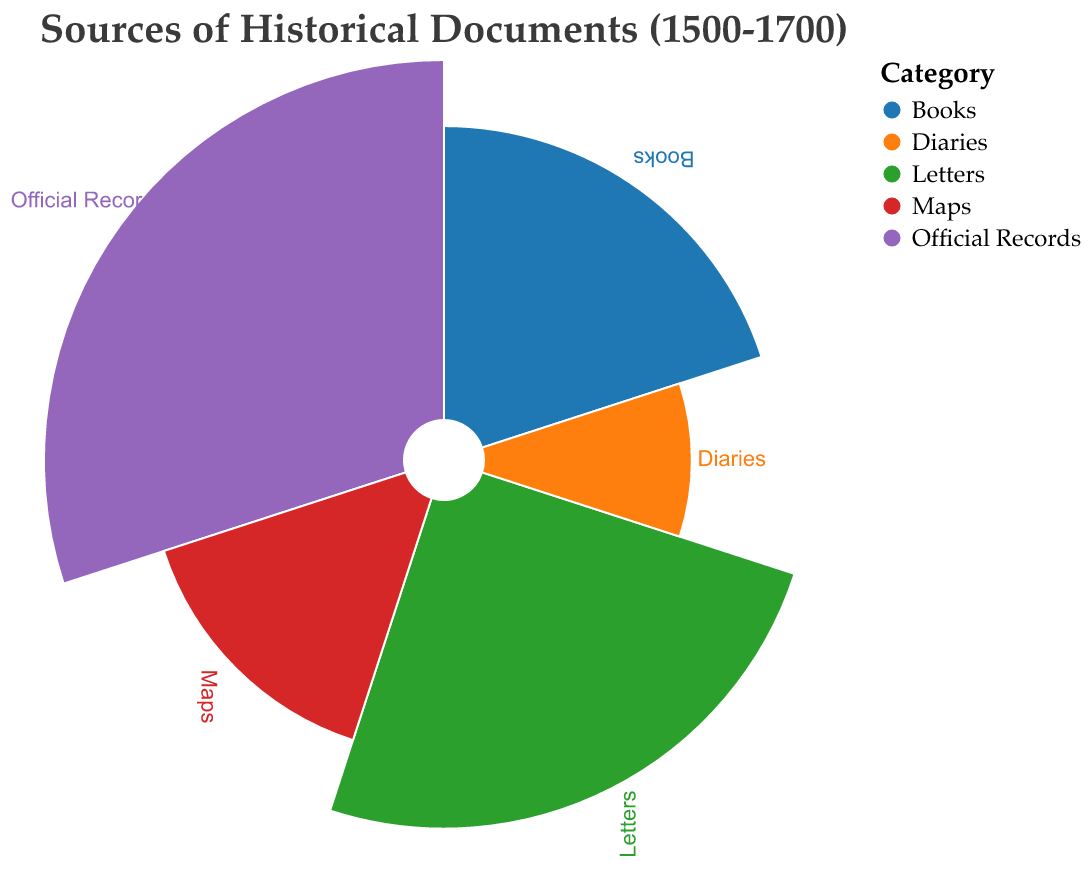what is the title of the chart? The title is located at the top center of the chart and reads "Sources of Historical Documents (1500-1700)."
Answer: Sources of Historical Documents (1500-1700) Which category represents the largest percentage? By examining the polar chart, we can see that the section with the label "Official Records" extends furthest in the radial direction, indicating that it has the largest percentage.
Answer: Official Records Which two categories combined make up more than half of the total percentage? Adding the percentages of "Official Records" (30%) and "Letters" (25%), we get 55%, which is more than half of the total.
Answer: Official Records and Letters Rank all the categories from the highest to lowest percentage. By visually assessing the segments, the rankings are: Official Records (30%), Letters (25%), Books (20%), Maps (15%), Diaries (10%).
Answer: Official Records, Letters, Books, Maps, Diaries How much greater is the percentage of Letters than the percentage of Diaries? Letters are 25% and Diaries are 10%, so the difference is 25% - 10% = 15%.
Answer: 15% What is the average percentage of Books and Maps? The percentage for Books is 20% and for Maps is 15%. To find the average: (20% + 15%) / 2 = 17.5%.
Answer: 17.5% Which category has half the percentage of Official Records? The percentage of Official Records is 30%. Half of 30% is 15%, which corresponds to Maps.
Answer: Maps What is the total percentage of the three largest categories combined? The three largest categories are Official Records (30%), Letters (25%), and Books (20%). Adding these: 30% + 25% + 20% = 75%.
Answer: 75% Which category has the smallest segment in the polar chart? By looking at the chart, the segment labeled "Diaries" is the smallest, indicating it has the lowest percentage.
Answer: Diaries If the percentages are doubled, which category would have the new highest percentage? Doubling the percentages gives Official Records 60%, Letters 50%, Maps 30%, Books 40%, and Diaries 20%. Official Records would still have the highest percentage.
Answer: Official Records 